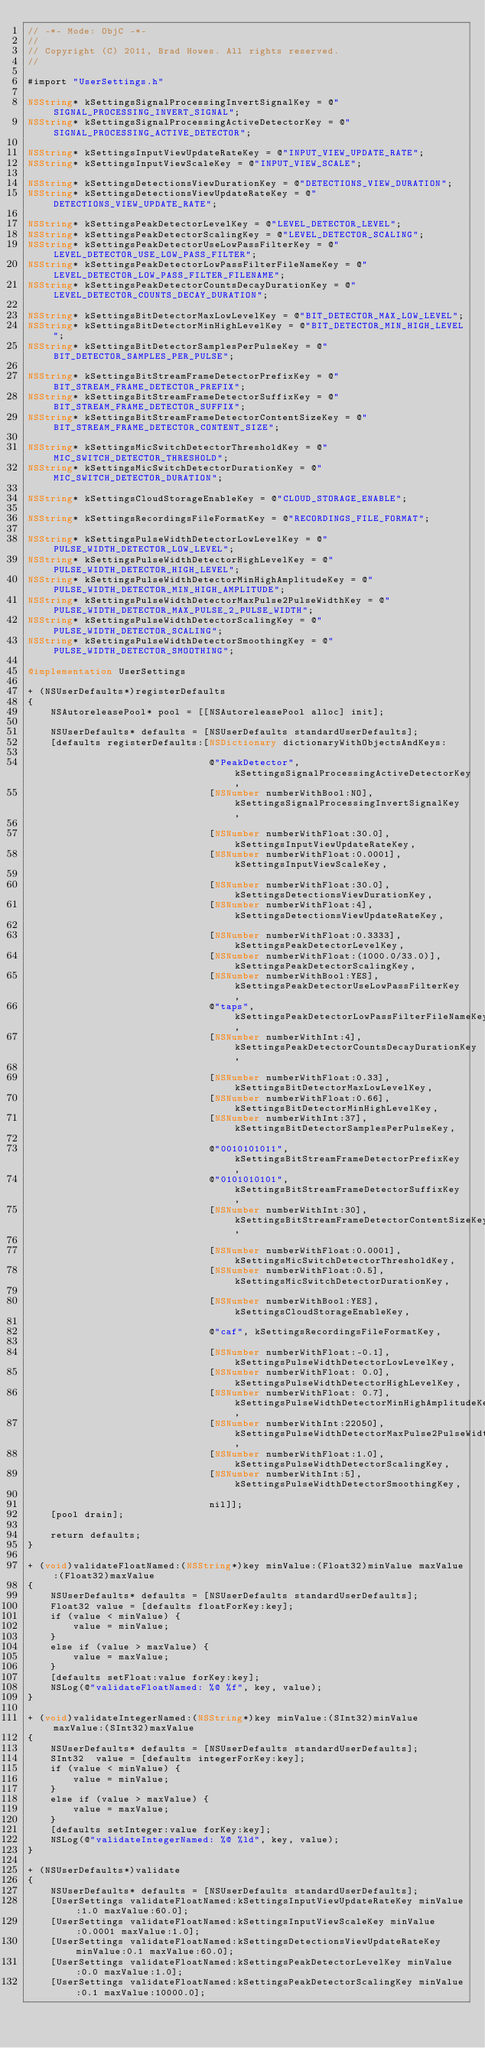Convert code to text. <code><loc_0><loc_0><loc_500><loc_500><_ObjectiveC_>// -*- Mode: ObjC -*-
//
// Copyright (C) 2011, Brad Howes. All rights reserved.
//

#import "UserSettings.h"

NSString* kSettingsSignalProcessingInvertSignalKey = @"SIGNAL_PROCESSING_INVERT_SIGNAL";
NSString* kSettingsSignalProcessingActiveDetectorKey = @"SIGNAL_PROCESSING_ACTIVE_DETECTOR";

NSString* kSettingsInputViewUpdateRateKey = @"INPUT_VIEW_UPDATE_RATE";
NSString* kSettingsInputViewScaleKey = @"INPUT_VIEW_SCALE";

NSString* kSettingsDetectionsViewDurationKey = @"DETECTIONS_VIEW_DURATION";
NSString* kSettingsDetectionsViewUpdateRateKey = @"DETECTIONS_VIEW_UPDATE_RATE";

NSString* kSettingsPeakDetectorLevelKey = @"LEVEL_DETECTOR_LEVEL";
NSString* kSettingsPeakDetectorScalingKey = @"LEVEL_DETECTOR_SCALING";
NSString* kSettingsPeakDetectorUseLowPassFilterKey = @"LEVEL_DETECTOR_USE_LOW_PASS_FILTER";
NSString* kSettingsPeakDetectorLowPassFilterFileNameKey = @"LEVEL_DETECTOR_LOW_PASS_FILTER_FILENAME";
NSString* kSettingsPeakDetectorCountsDecayDurationKey = @"LEVEL_DETECTOR_COUNTS_DECAY_DURATION";

NSString* kSettingsBitDetectorMaxLowLevelKey = @"BIT_DETECTOR_MAX_LOW_LEVEL";
NSString* kSettingsBitDetectorMinHighLevelKey = @"BIT_DETECTOR_MIN_HIGH_LEVEL";
NSString* kSettingsBitDetectorSamplesPerPulseKey = @"BIT_DETECTOR_SAMPLES_PER_PULSE";

NSString* kSettingsBitStreamFrameDetectorPrefixKey = @"BIT_STREAM_FRAME_DETECTOR_PREFIX";
NSString* kSettingsBitStreamFrameDetectorSuffixKey = @"BIT_STREAM_FRAME_DETECTOR_SUFFIX";
NSString* kSettingsBitStreamFrameDetectorContentSizeKey = @"BIT_STREAM_FRAME_DETECTOR_CONTENT_SIZE";

NSString* kSettingsMicSwitchDetectorThresholdKey = @"MIC_SWITCH_DETECTOR_THRESHOLD";
NSString* kSettingsMicSwitchDetectorDurationKey = @"MIC_SWITCH_DETECTOR_DURATION";

NSString* kSettingsCloudStorageEnableKey = @"CLOUD_STORAGE_ENABLE";

NSString* kSettingsRecordingsFileFormatKey = @"RECORDINGS_FILE_FORMAT";

NSString* kSettingsPulseWidthDetectorLowLevelKey = @"PULSE_WIDTH_DETECTOR_LOW_LEVEL";
NSString* kSettingsPulseWidthDetectorHighLevelKey = @"PULSE_WIDTH_DETECTOR_HIGH_LEVEL";
NSString* kSettingsPulseWidthDetectorMinHighAmplitudeKey = @"PULSE_WIDTH_DETECTOR_MIN_HIGH_AMPLITUDE";
NSString* kSettingsPulseWidthDetectorMaxPulse2PulseWidthKey = @"PULSE_WIDTH_DETECTOR_MAX_PULSE_2_PULSE_WIDTH";
NSString* kSettingsPulseWidthDetectorScalingKey = @"PULSE_WIDTH_DETECTOR_SCALING";
NSString* kSettingsPulseWidthDetectorSmoothingKey = @"PULSE_WIDTH_DETECTOR_SMOOTHING";

@implementation UserSettings

+ (NSUserDefaults*)registerDefaults
{
    NSAutoreleasePool* pool = [[NSAutoreleasePool alloc] init];
    
    NSUserDefaults* defaults = [NSUserDefaults standardUserDefaults];
    [defaults registerDefaults:[NSDictionary dictionaryWithObjectsAndKeys:
                                
                                @"PeakDetector", kSettingsSignalProcessingActiveDetectorKey,
                                [NSNumber numberWithBool:NO], kSettingsSignalProcessingInvertSignalKey,
                                
                                [NSNumber numberWithFloat:30.0], kSettingsInputViewUpdateRateKey,
                                [NSNumber numberWithFloat:0.0001], kSettingsInputViewScaleKey,
                                
                                [NSNumber numberWithFloat:30.0], kSettingsDetectionsViewDurationKey,
                                [NSNumber numberWithFloat:4], kSettingsDetectionsViewUpdateRateKey,
                                
                                [NSNumber numberWithFloat:0.3333], kSettingsPeakDetectorLevelKey,
                                [NSNumber numberWithFloat:(1000.0/33.0)], kSettingsPeakDetectorScalingKey,
                                [NSNumber numberWithBool:YES], kSettingsPeakDetectorUseLowPassFilterKey,
                                @"taps", kSettingsPeakDetectorLowPassFilterFileNameKey,
                                [NSNumber numberWithInt:4], kSettingsPeakDetectorCountsDecayDurationKey,
                                
                                [NSNumber numberWithFloat:0.33], kSettingsBitDetectorMaxLowLevelKey,
                                [NSNumber numberWithFloat:0.66], kSettingsBitDetectorMinHighLevelKey,
                                [NSNumber numberWithInt:37], kSettingsBitDetectorSamplesPerPulseKey,
                                
                                @"0010101011", kSettingsBitStreamFrameDetectorPrefixKey,
                                @"0101010101", kSettingsBitStreamFrameDetectorSuffixKey,
                                [NSNumber numberWithInt:30], kSettingsBitStreamFrameDetectorContentSizeKey,
                                
                                [NSNumber numberWithFloat:0.0001], kSettingsMicSwitchDetectorThresholdKey,
                                [NSNumber numberWithFloat:0.5], kSettingsMicSwitchDetectorDurationKey,
                                
                                [NSNumber numberWithBool:YES], kSettingsCloudStorageEnableKey,
                                
                                @"caf", kSettingsRecordingsFileFormatKey,
                                
                                [NSNumber numberWithFloat:-0.1], kSettingsPulseWidthDetectorLowLevelKey,
                                [NSNumber numberWithFloat: 0.0], kSettingsPulseWidthDetectorHighLevelKey,
                                [NSNumber numberWithFloat: 0.7], kSettingsPulseWidthDetectorMinHighAmplitudeKey,
                                [NSNumber numberWithInt:22050], kSettingsPulseWidthDetectorMaxPulse2PulseWidthKey,
                                [NSNumber numberWithFloat:1.0], kSettingsPulseWidthDetectorScalingKey,
                                [NSNumber numberWithInt:5], kSettingsPulseWidthDetectorSmoothingKey,
                                
                                nil]];
    [pool drain];
    
    return defaults;
}

+ (void)validateFloatNamed:(NSString*)key minValue:(Float32)minValue maxValue:(Float32)maxValue
{
    NSUserDefaults* defaults = [NSUserDefaults standardUserDefaults];
    Float32	value = [defaults floatForKey:key];
    if (value < minValue) {
        value = minValue;
    }
    else if	(value > maxValue) {
        value = maxValue;
    }
    [defaults setFloat:value forKey:key];
    NSLog(@"validateFloatNamed: %@ %f", key, value);
}

+ (void)validateIntegerNamed:(NSString*)key minValue:(SInt32)minValue maxValue:(SInt32)maxValue
{
    NSUserDefaults* defaults = [NSUserDefaults standardUserDefaults];
    SInt32	value = [defaults integerForKey:key];
    if (value < minValue) {
        value = minValue;
    }
    else if	(value > maxValue) {
        value = maxValue;
    }
    [defaults setInteger:value forKey:key];
    NSLog(@"validateIntegerNamed: %@ %ld", key, value);
}

+ (NSUserDefaults*)validate
{
    NSUserDefaults* defaults = [NSUserDefaults standardUserDefaults];
    [UserSettings validateFloatNamed:kSettingsInputViewUpdateRateKey minValue:1.0 maxValue:60.0];
    [UserSettings validateFloatNamed:kSettingsInputViewScaleKey minValue:0.0001 maxValue:1.0];
    [UserSettings validateFloatNamed:kSettingsDetectionsViewUpdateRateKey minValue:0.1 maxValue:60.0];
    [UserSettings validateFloatNamed:kSettingsPeakDetectorLevelKey minValue:0.0 maxValue:1.0];
    [UserSettings validateFloatNamed:kSettingsPeakDetectorScalingKey minValue:0.1 maxValue:10000.0];</code> 